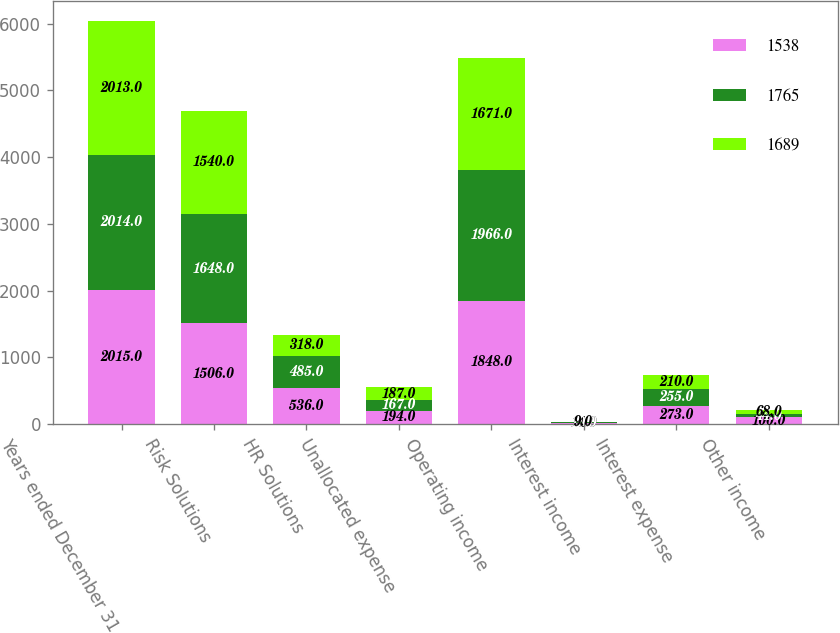<chart> <loc_0><loc_0><loc_500><loc_500><stacked_bar_chart><ecel><fcel>Years ended December 31<fcel>Risk Solutions<fcel>HR Solutions<fcel>Unallocated expense<fcel>Operating income<fcel>Interest income<fcel>Interest expense<fcel>Other income<nl><fcel>1538<fcel>2015<fcel>1506<fcel>536<fcel>194<fcel>1848<fcel>14<fcel>273<fcel>100<nl><fcel>1765<fcel>2014<fcel>1648<fcel>485<fcel>167<fcel>1966<fcel>10<fcel>255<fcel>44<nl><fcel>1689<fcel>2013<fcel>1540<fcel>318<fcel>187<fcel>1671<fcel>9<fcel>210<fcel>68<nl></chart> 